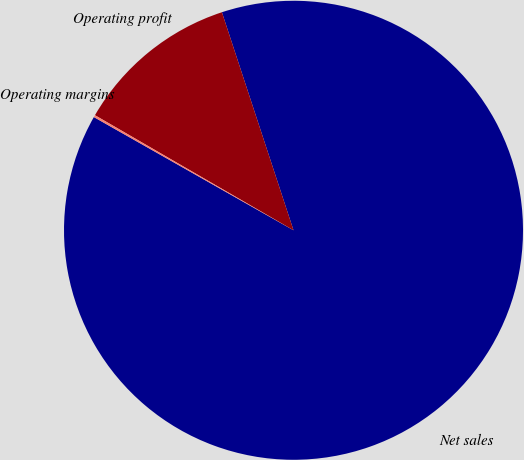Convert chart to OTSL. <chart><loc_0><loc_0><loc_500><loc_500><pie_chart><fcel>Net sales<fcel>Operating profit<fcel>Operating margins<nl><fcel>88.26%<fcel>11.59%<fcel>0.15%<nl></chart> 